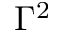Convert formula to latex. <formula><loc_0><loc_0><loc_500><loc_500>\Gamma ^ { 2 }</formula> 